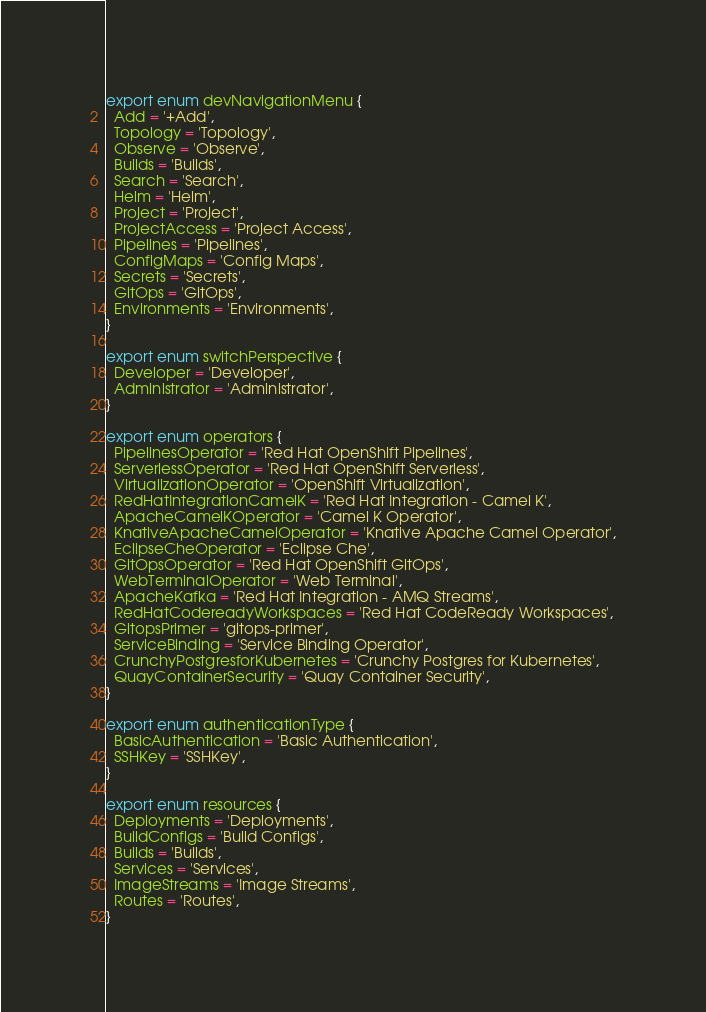<code> <loc_0><loc_0><loc_500><loc_500><_TypeScript_>export enum devNavigationMenu {
  Add = '+Add',
  Topology = 'Topology',
  Observe = 'Observe',
  Builds = 'Builds',
  Search = 'Search',
  Helm = 'Helm',
  Project = 'Project',
  ProjectAccess = 'Project Access',
  Pipelines = 'Pipelines',
  ConfigMaps = 'Config Maps',
  Secrets = 'Secrets',
  GitOps = 'GitOps',
  Environments = 'Environments',
}

export enum switchPerspective {
  Developer = 'Developer',
  Administrator = 'Administrator',
}

export enum operators {
  PipelinesOperator = 'Red Hat OpenShift Pipelines',
  ServerlessOperator = 'Red Hat OpenShift Serverless',
  VirtualizationOperator = 'OpenShift Virtualization',
  RedHatIntegrationCamelK = 'Red Hat Integration - Camel K',
  ApacheCamelKOperator = 'Camel K Operator',
  KnativeApacheCamelOperator = 'Knative Apache Camel Operator',
  EclipseCheOperator = 'Eclipse Che',
  GitOpsOperator = 'Red Hat OpenShift GitOps',
  WebTerminalOperator = 'Web Terminal',
  ApacheKafka = 'Red Hat Integration - AMQ Streams',
  RedHatCodereadyWorkspaces = 'Red Hat CodeReady Workspaces',
  GitopsPrimer = 'gitops-primer',
  ServiceBinding = 'Service Binding Operator',
  CrunchyPostgresforKubernetes = 'Crunchy Postgres for Kubernetes',
  QuayContainerSecurity = 'Quay Container Security',
}

export enum authenticationType {
  BasicAuthentication = 'Basic Authentication',
  SSHKey = 'SSHKey',
}

export enum resources {
  Deployments = 'Deployments',
  BuildConfigs = 'Build Configs',
  Builds = 'Builds',
  Services = 'Services',
  ImageStreams = 'Image Streams',
  Routes = 'Routes',
}
</code> 